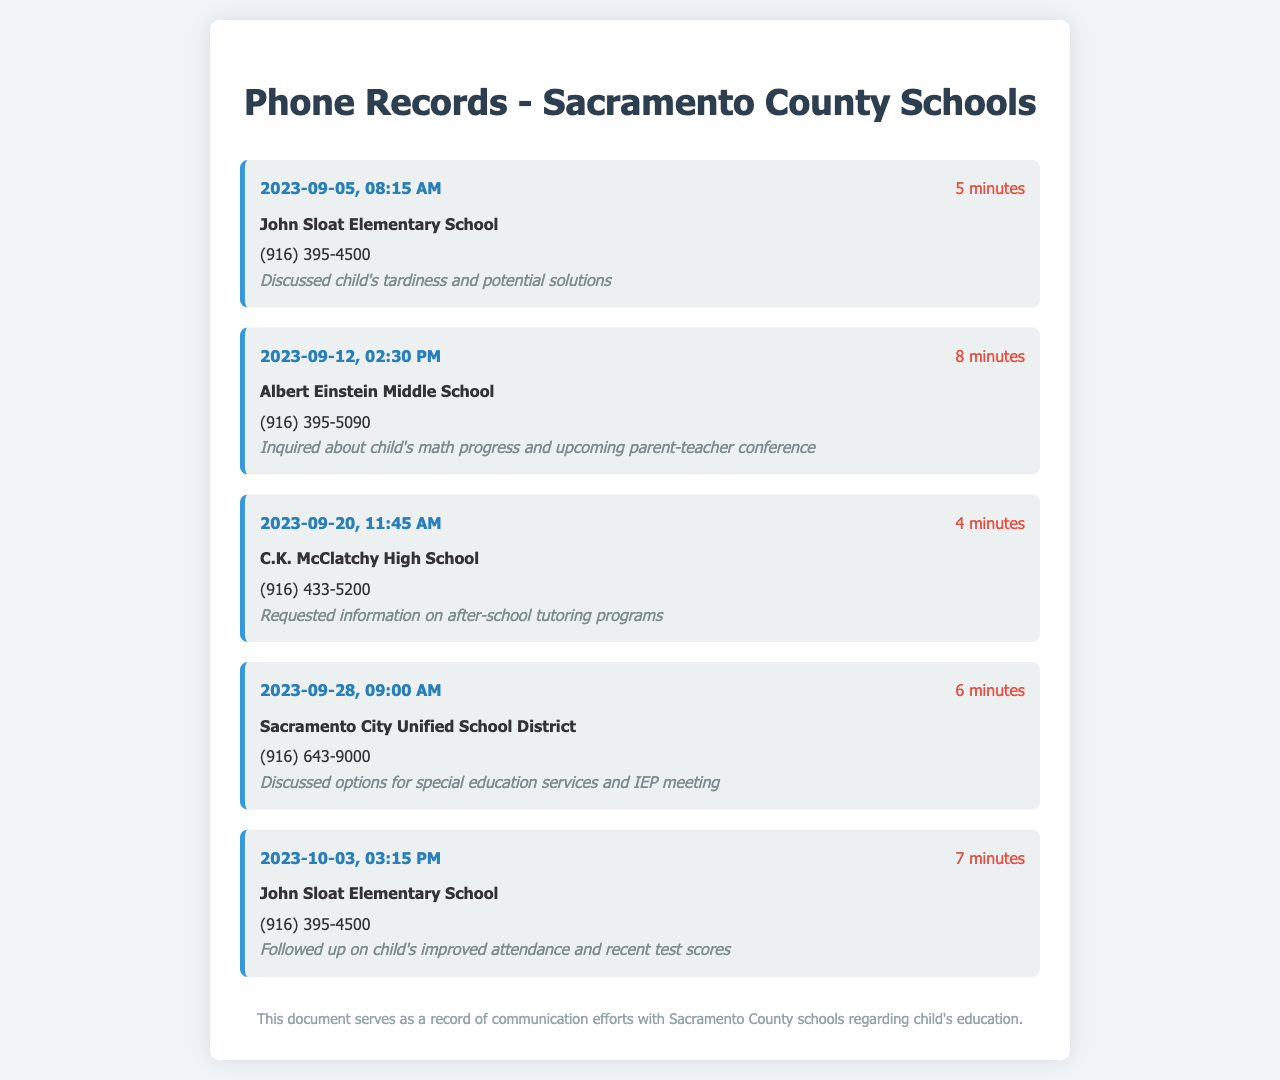What is the date of the first communication? The first communication recorded is on September 5, 2023.
Answer: September 5, 2023 How long was the call with Albert Einstein Middle School? The duration of the call on September 12, 2023, was 8 minutes.
Answer: 8 minutes What school was contacted regarding after-school tutoring? The school contacted for information on tutoring programs is C.K. McClatchy High School.
Answer: C.K. McClatchy High School What is the contact number for John Sloat Elementary School? The number for John Sloat Elementary School is (916) 395-4500, as stated in two records.
Answer: (916) 395-4500 Which topic was discussed on October 3, 2023? The discussion on October 3, 2023, was about the child's improved attendance and test scores.
Answer: Improved attendance and recent test scores What was the purpose of the call on September 28, 2023? The purpose of that call was to discuss options for special education services and an IEP meeting.
Answer: Special education services and IEP meeting How many minutes did the communication with Sacramento City Unified School District take? The communication on September 28, 2023, took 6 minutes.
Answer: 6 minutes Which school was the last one contacted? The last school contacted, according to the records, was John Sloat Elementary School.
Answer: John Sloat Elementary School 